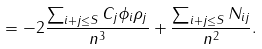Convert formula to latex. <formula><loc_0><loc_0><loc_500><loc_500>= - 2 \frac { \sum _ { i + j \leq S } C _ { j } \phi _ { i } \rho _ { j } } { n ^ { 3 } } + \frac { \sum _ { i + j \leq S } N _ { i j } } { n ^ { 2 } } .</formula> 